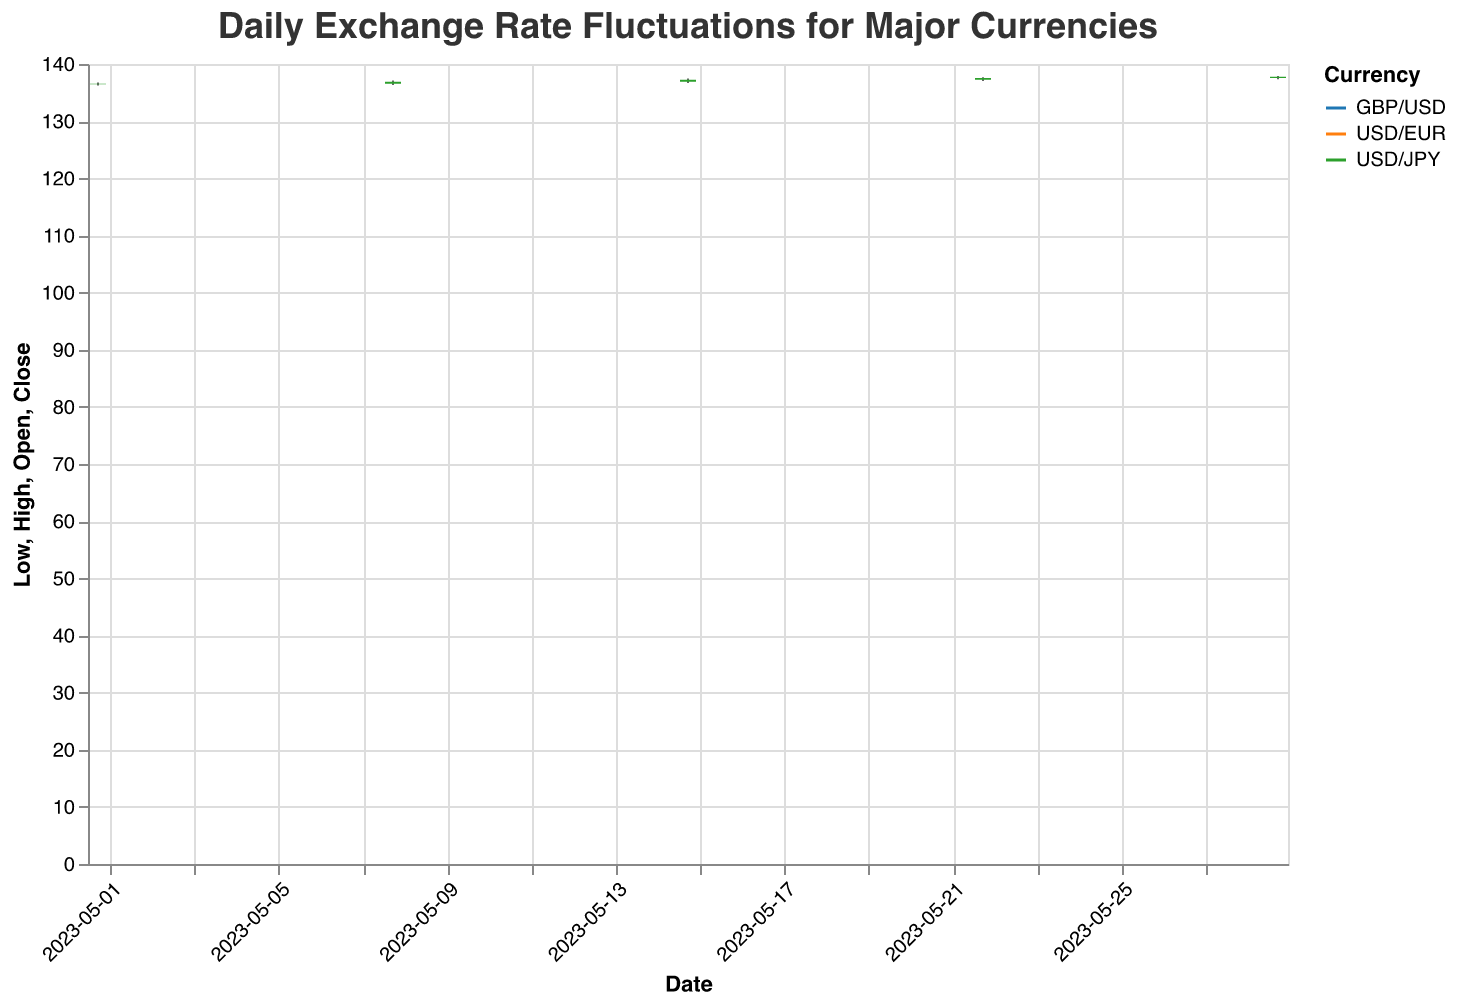What's the title of the figure? The title of the figure is displayed at the top and reads "Daily Exchange Rate Fluctuations for Major Currencies".
Answer: Daily Exchange Rate Fluctuations for Major Currencies What are the three currencies shown in the chart? By observing the color legends and tooltip information, we see the currencies depicted are "USD/EUR", "GBP/USD", and "USD/JPY".
Answer: USD/EUR, GBP/USD, and USD/JPY What is the closing price of USD/EUR on May 15, 2023? Select the candlestick for USD/EUR on May 15, 2023, and look at the Close value in the tooltip. The closing price is 0.9176.
Answer: 0.9176 Which currency showed the highest high value on May 29, 2023? Compare the high values for each currency on May 29, 2023, by checking the tooltips. The highest high value is for USD/JPY at 137.92.
Answer: USD/JPY What is the average closing price of GBP/USD across the dates shown? Sum the closing prices for GBP/USD on each date (1.2518 + 1.2543 + 1.2572 + 1.2598 + 1.2621), then divide by the number of dates (5): (1.2518 + 1.2543 + 1.2572 + 1.2598 + 1.2621)/5. The average is 1.25704.
Answer: 1.25704 Which currency shows the most volatility over the given period? To determine the currency with the most volatility, we compare the range (High - Low) of each currency. By examining the ranges, USD/JPY shows the largest fluctuations.
Answer: USD/JPY Is there a general trend in the USD/EUR exchange rate over the given period? Observing the overall direction of the closing values, we see a gradual increase from 0.9131 on May 1st to 0.9203 on May 29th.
Answer: Increasing By how much did the closing price of GBP/USD increase from May 1 to May 29? Subtract the closing price of May 1 (1.2518) from the closing price on May 29 (1.2621): 1.2621 - 1.2518. The increase is 0.0103.
Answer: 0.0103 What is the lowest closing price for USD/JPY and when did it occur? Identify the lowest closing price for USD/JPY by examining all dates. The lowest closing price is on May 1st, at 136.54.
Answer: 136.54 on May 1 Between May 15 and May 29, did USD/EUR experience any significant increase or decrease in closing prices? Compare the closing prices of USD/EUR on May 15 (0.9176) and May 29 (0.9203). There is a noticeable increase.
Answer: Increase 